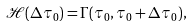<formula> <loc_0><loc_0><loc_500><loc_500>\mathcal { H } ( \Delta \tau _ { 0 } ) = \Gamma ( \tau _ { 0 } , \tau _ { 0 } + \Delta \tau _ { 0 } ) ,</formula> 